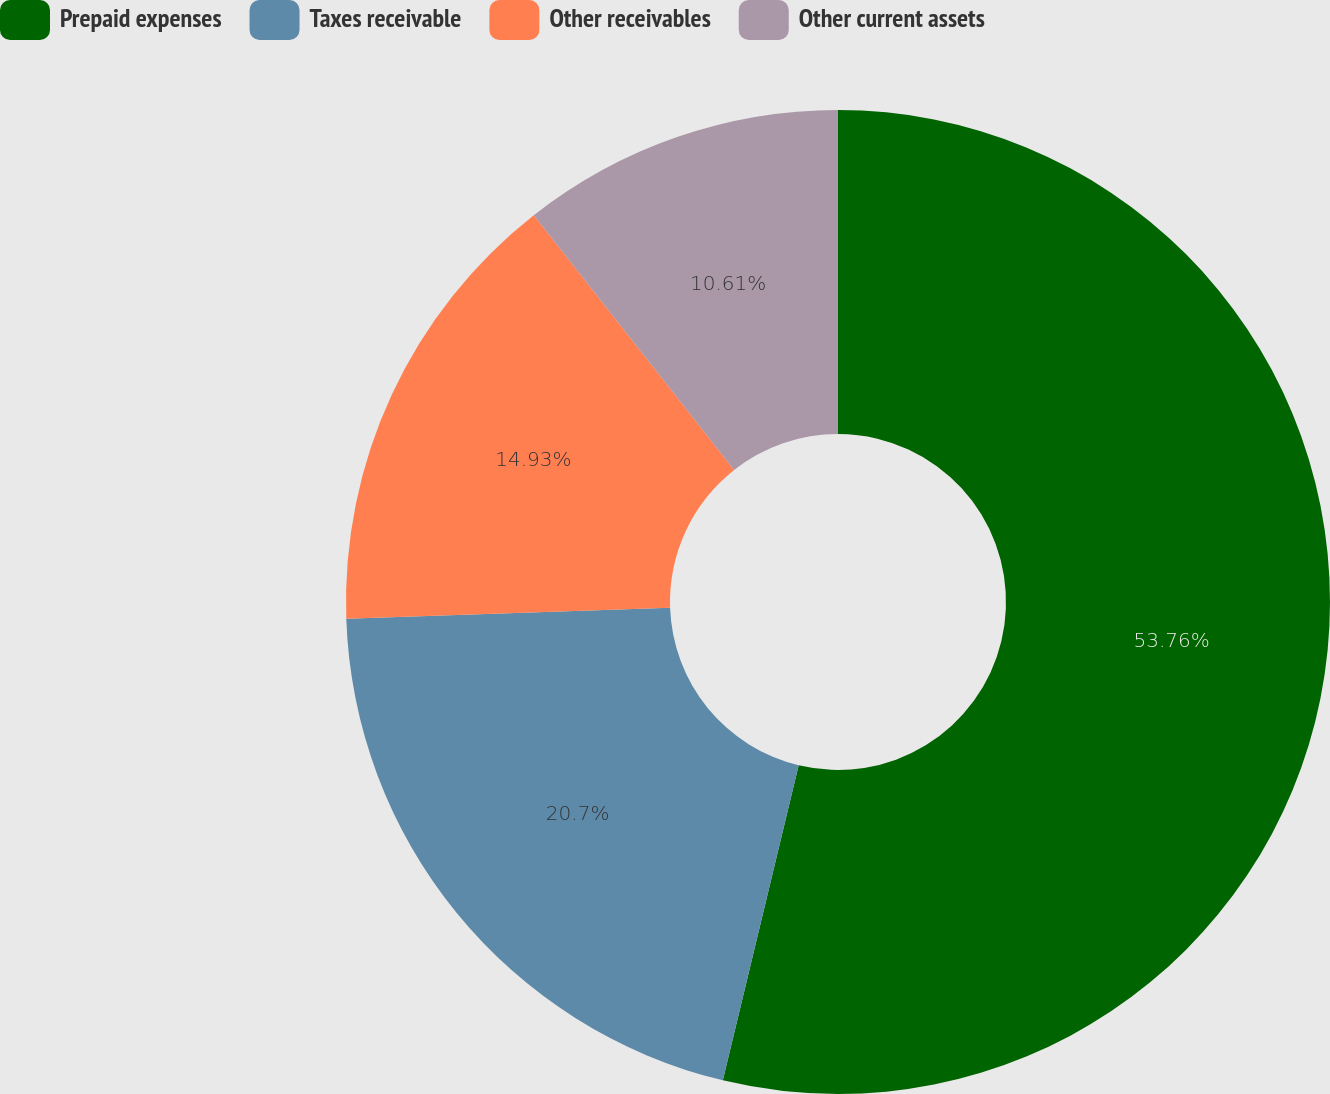<chart> <loc_0><loc_0><loc_500><loc_500><pie_chart><fcel>Prepaid expenses<fcel>Taxes receivable<fcel>Other receivables<fcel>Other current assets<nl><fcel>53.76%<fcel>20.7%<fcel>14.93%<fcel>10.61%<nl></chart> 